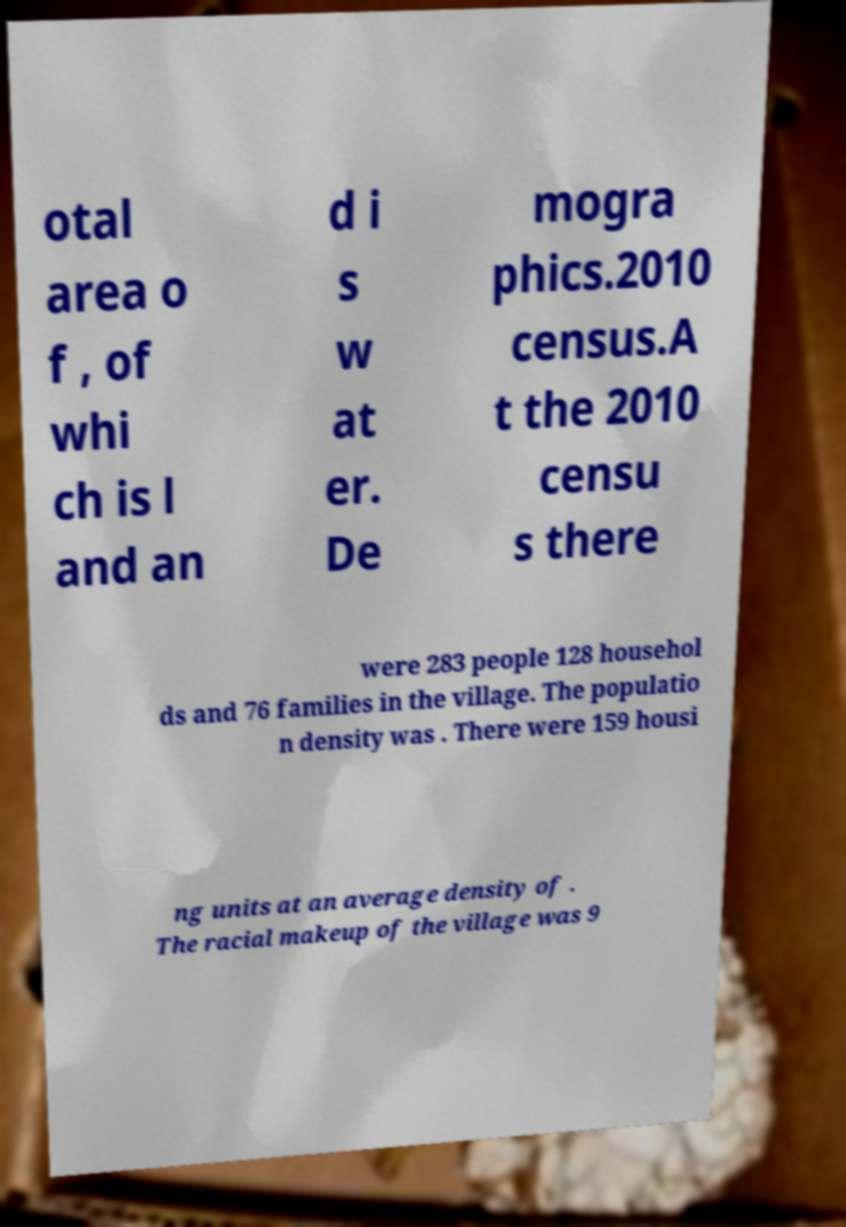Please identify and transcribe the text found in this image. otal area o f , of whi ch is l and an d i s w at er. De mogra phics.2010 census.A t the 2010 censu s there were 283 people 128 househol ds and 76 families in the village. The populatio n density was . There were 159 housi ng units at an average density of . The racial makeup of the village was 9 